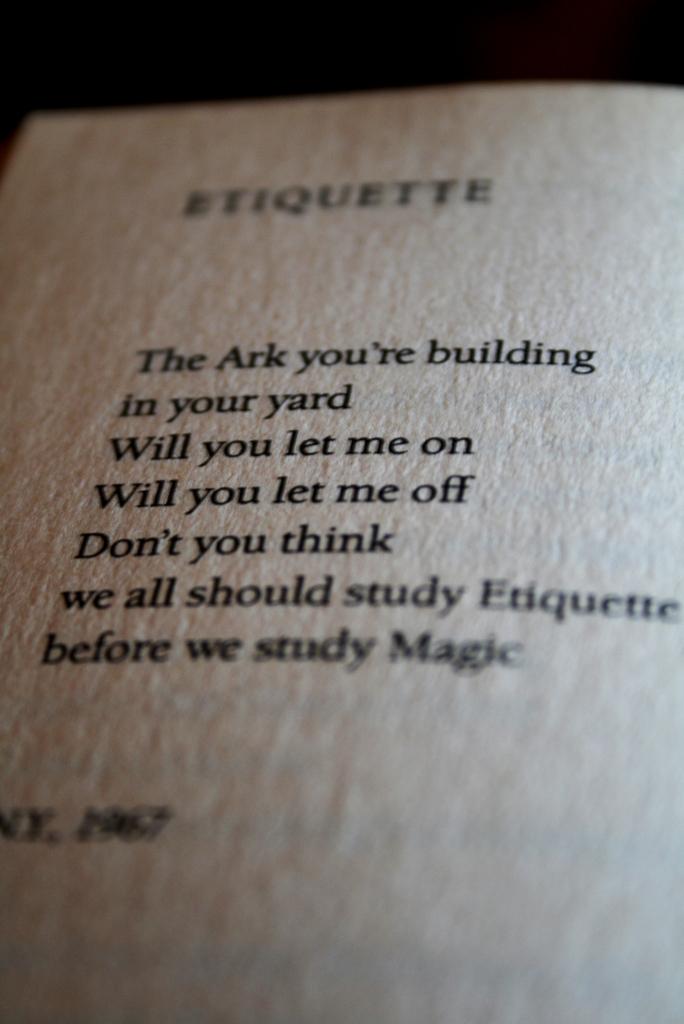What are they building?
Keep it short and to the point. The ark. 